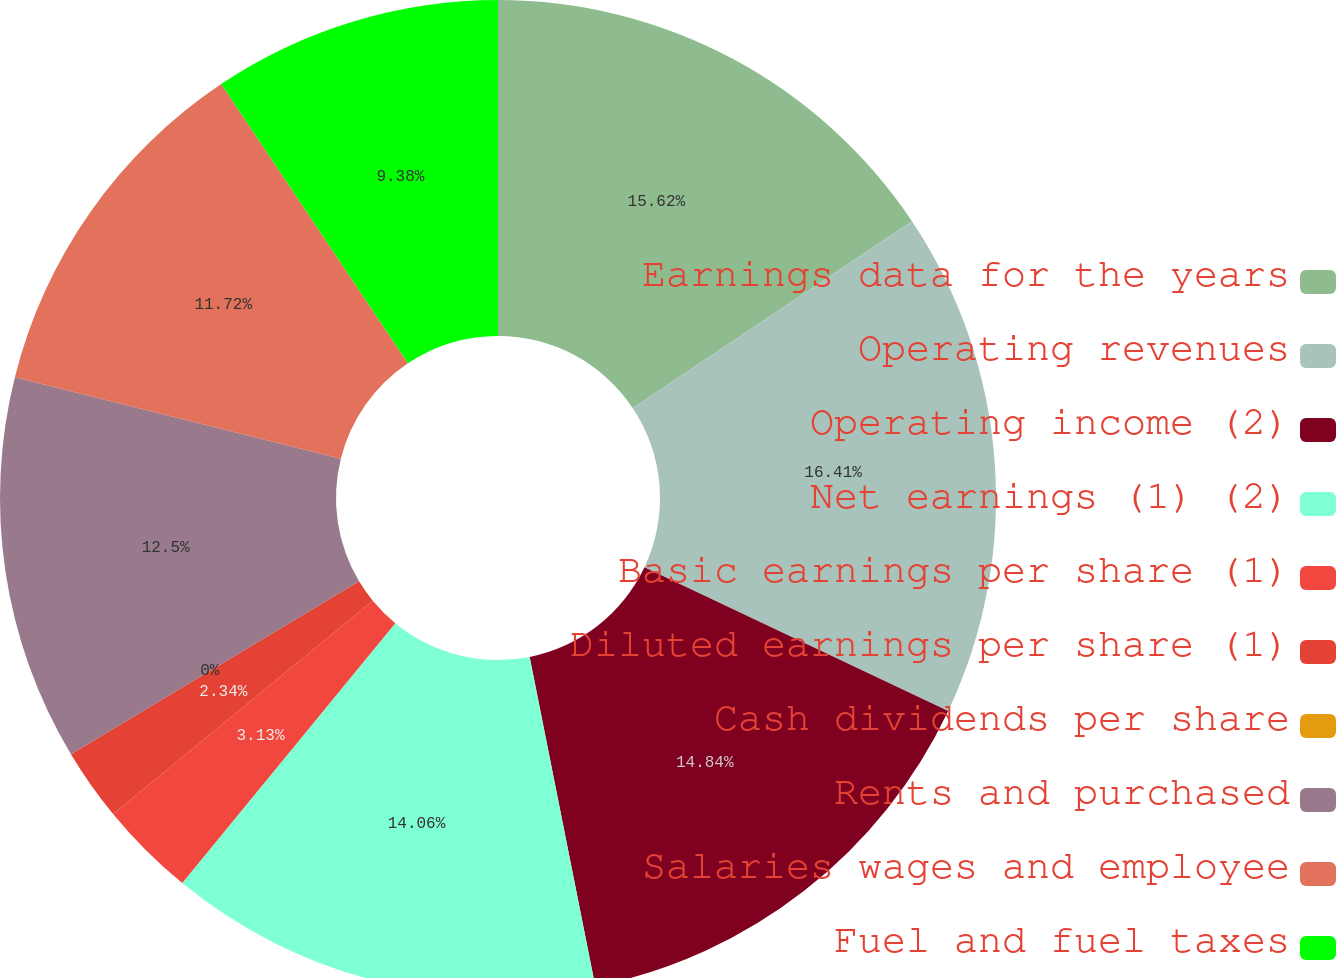Convert chart. <chart><loc_0><loc_0><loc_500><loc_500><pie_chart><fcel>Earnings data for the years<fcel>Operating revenues<fcel>Operating income (2)<fcel>Net earnings (1) (2)<fcel>Basic earnings per share (1)<fcel>Diluted earnings per share (1)<fcel>Cash dividends per share<fcel>Rents and purchased<fcel>Salaries wages and employee<fcel>Fuel and fuel taxes<nl><fcel>15.62%<fcel>16.41%<fcel>14.84%<fcel>14.06%<fcel>3.13%<fcel>2.34%<fcel>0.0%<fcel>12.5%<fcel>11.72%<fcel>9.38%<nl></chart> 